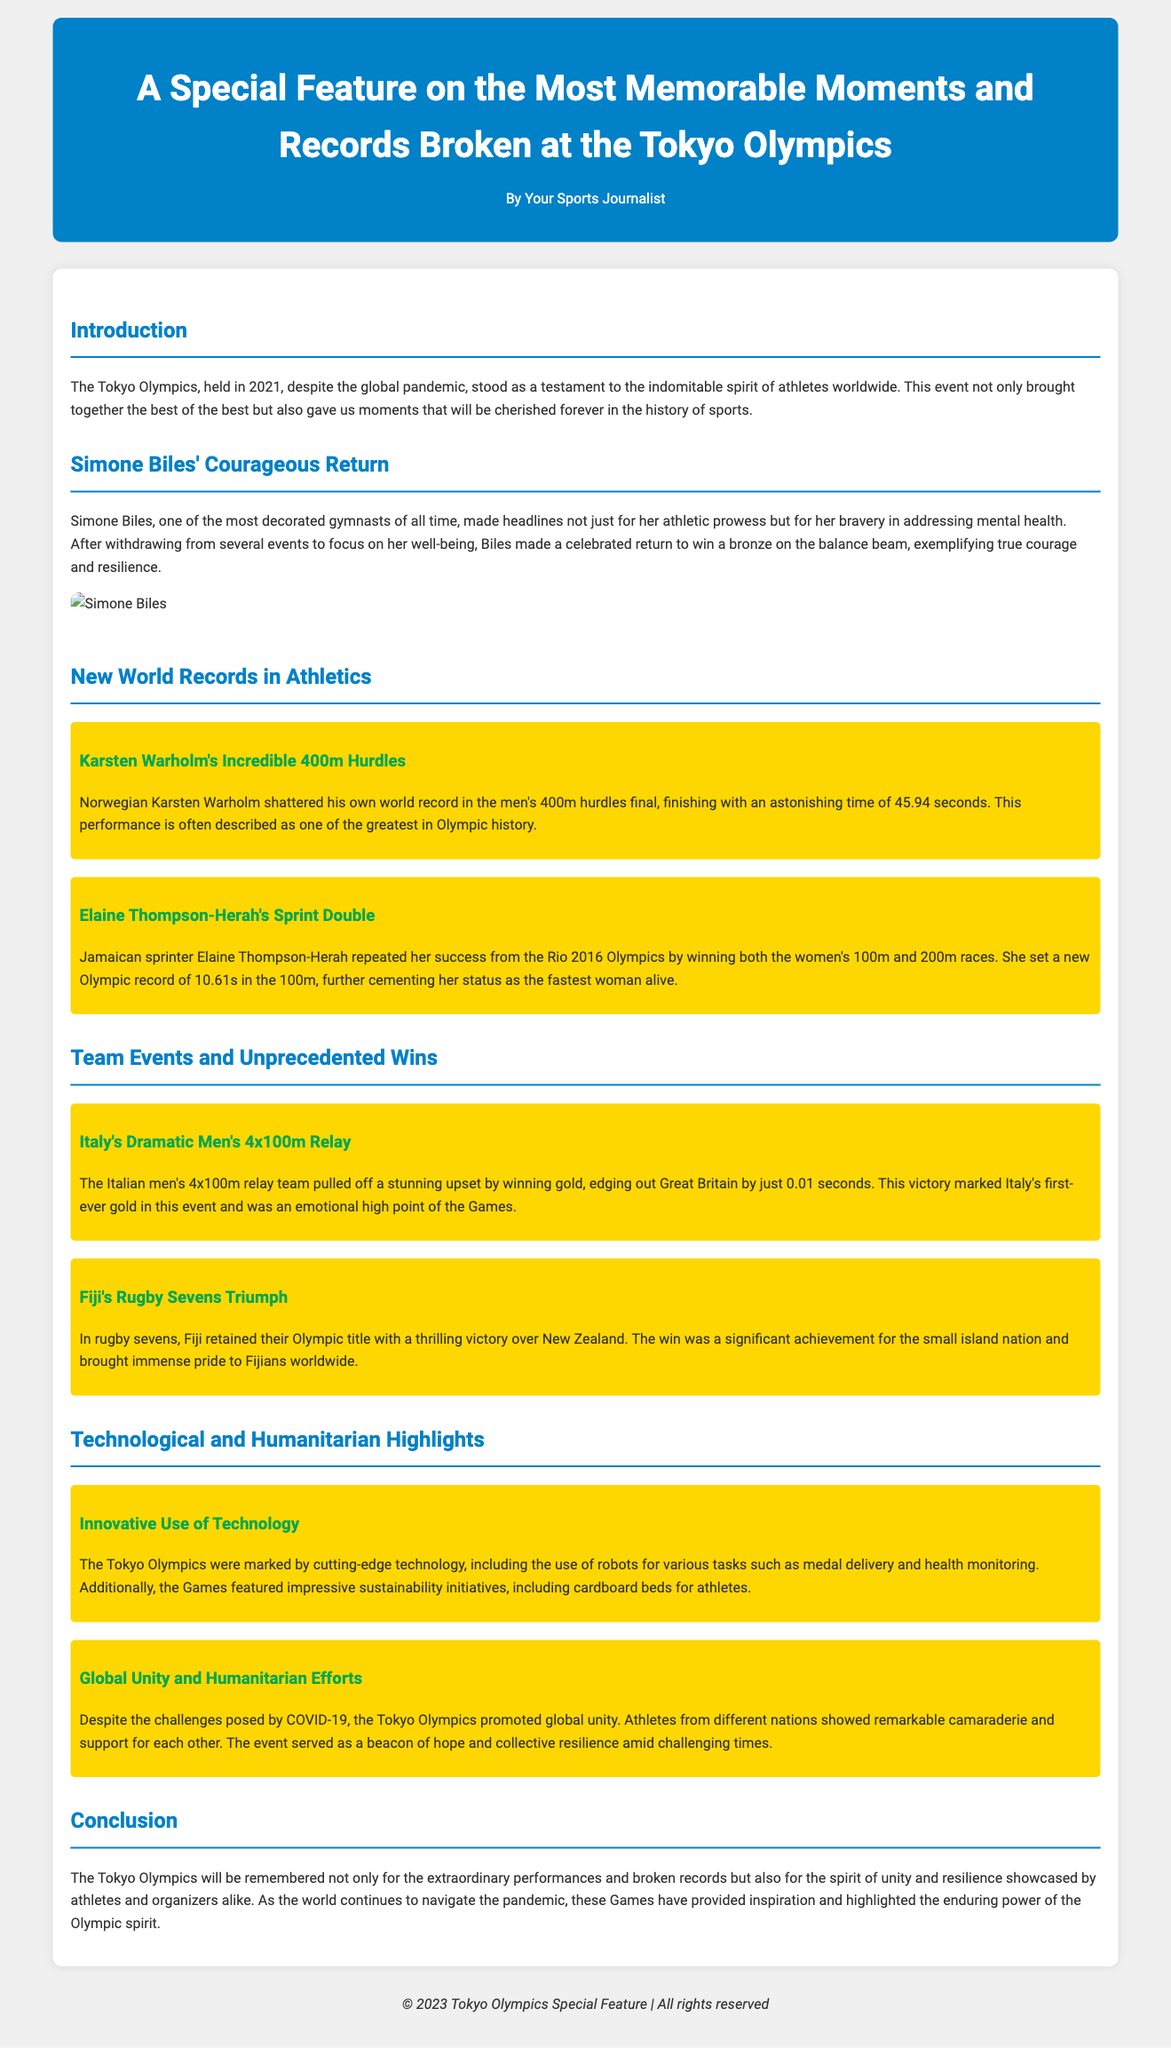what year were the Tokyo Olympics held? The Tokyo Olympics took place in 2021.
Answer: 2021 who won a bronze medal on the balance beam? Simone Biles returned to compete and won a bronze medal in this event.
Answer: Simone Biles what was Karsten Warholm's record time in the 400m hurdles? Warholm finished with an astonishing time of 45.94 seconds, breaking his own world record.
Answer: 45.94 seconds which country won gold in the men's 4x100m relay? Italy's men's 4x100m relay team won the gold medal.
Answer: Italy what notable achievement did Elaine Thompson-Herah accomplish? She won both the women's 100m and 200m races, setting a new Olympic record in the 100m.
Answer: Sprint double how did the Tokyo Olympics promote global unity? Athletes from different nations showcased remarkable camaraderie and support for each other.
Answer: Camaraderie what innovative technology was used at the Tokyo Olympics? The Games included the use of robots for medal delivery and health monitoring.
Answer: Robots what significant sustainable initiative was introduced for athletes? The Olympics featured cardboard beds for athletes.
Answer: Cardboard beds how is the Tokyo Olympics remembered according to the conclusion? The Games are remembered for extraordinary performances and the spirit of unity.
Answer: Spirit of unity 